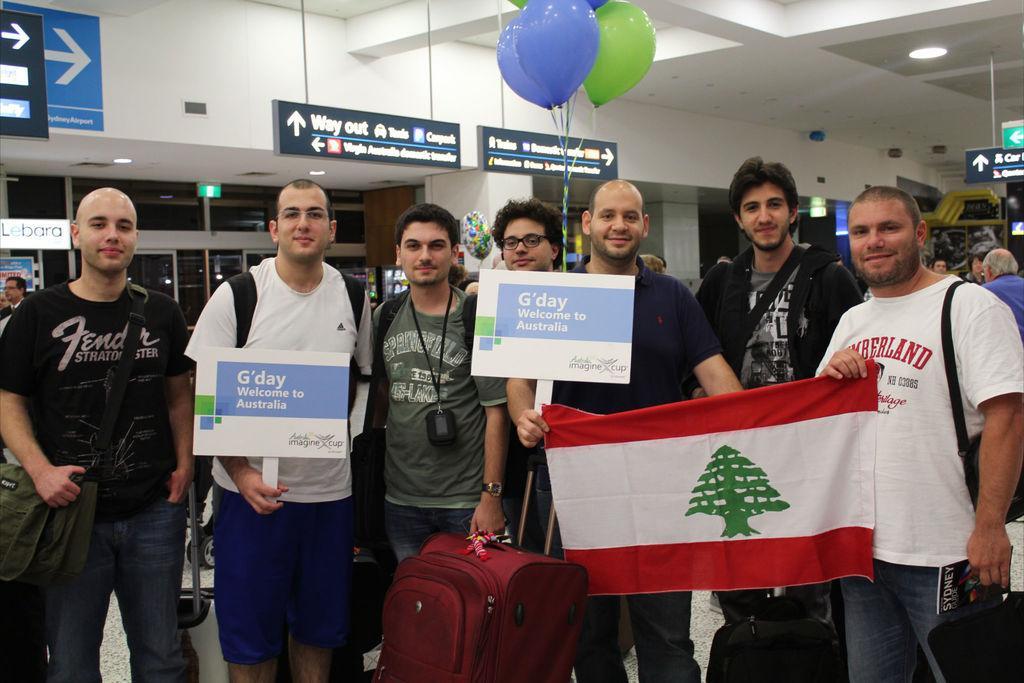Please provide a concise description of this image. In this picture we can see a group of people are standing and some of them are holding boards, flag and carrying bags. In the background of the image we can see the boards, balloons, lights, wall, sign boards, pillars. At the top of the image we can see the roof. At the bottom of the image we can see the floor. In the background of the image we can see some people. 